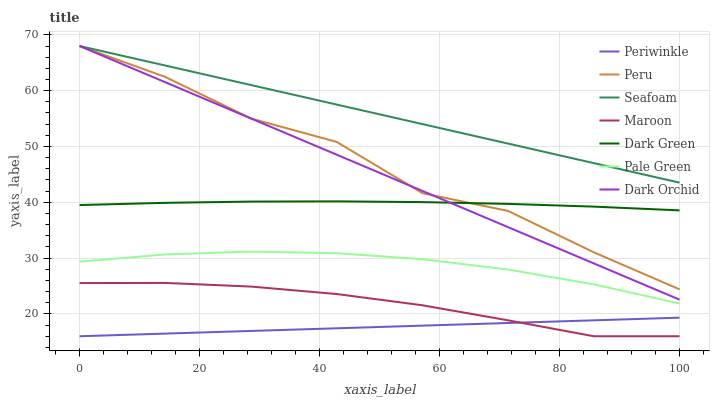Does Periwinkle have the minimum area under the curve?
Answer yes or no. Yes. Does Seafoam have the maximum area under the curve?
Answer yes or no. Yes. Does Maroon have the minimum area under the curve?
Answer yes or no. No. Does Maroon have the maximum area under the curve?
Answer yes or no. No. Is Periwinkle the smoothest?
Answer yes or no. Yes. Is Peru the roughest?
Answer yes or no. Yes. Is Maroon the smoothest?
Answer yes or no. No. Is Maroon the roughest?
Answer yes or no. No. Does Maroon have the lowest value?
Answer yes or no. Yes. Does Pale Green have the lowest value?
Answer yes or no. No. Does Peru have the highest value?
Answer yes or no. Yes. Does Maroon have the highest value?
Answer yes or no. No. Is Periwinkle less than Dark Green?
Answer yes or no. Yes. Is Dark Green greater than Periwinkle?
Answer yes or no. Yes. Does Dark Orchid intersect Dark Green?
Answer yes or no. Yes. Is Dark Orchid less than Dark Green?
Answer yes or no. No. Is Dark Orchid greater than Dark Green?
Answer yes or no. No. Does Periwinkle intersect Dark Green?
Answer yes or no. No. 